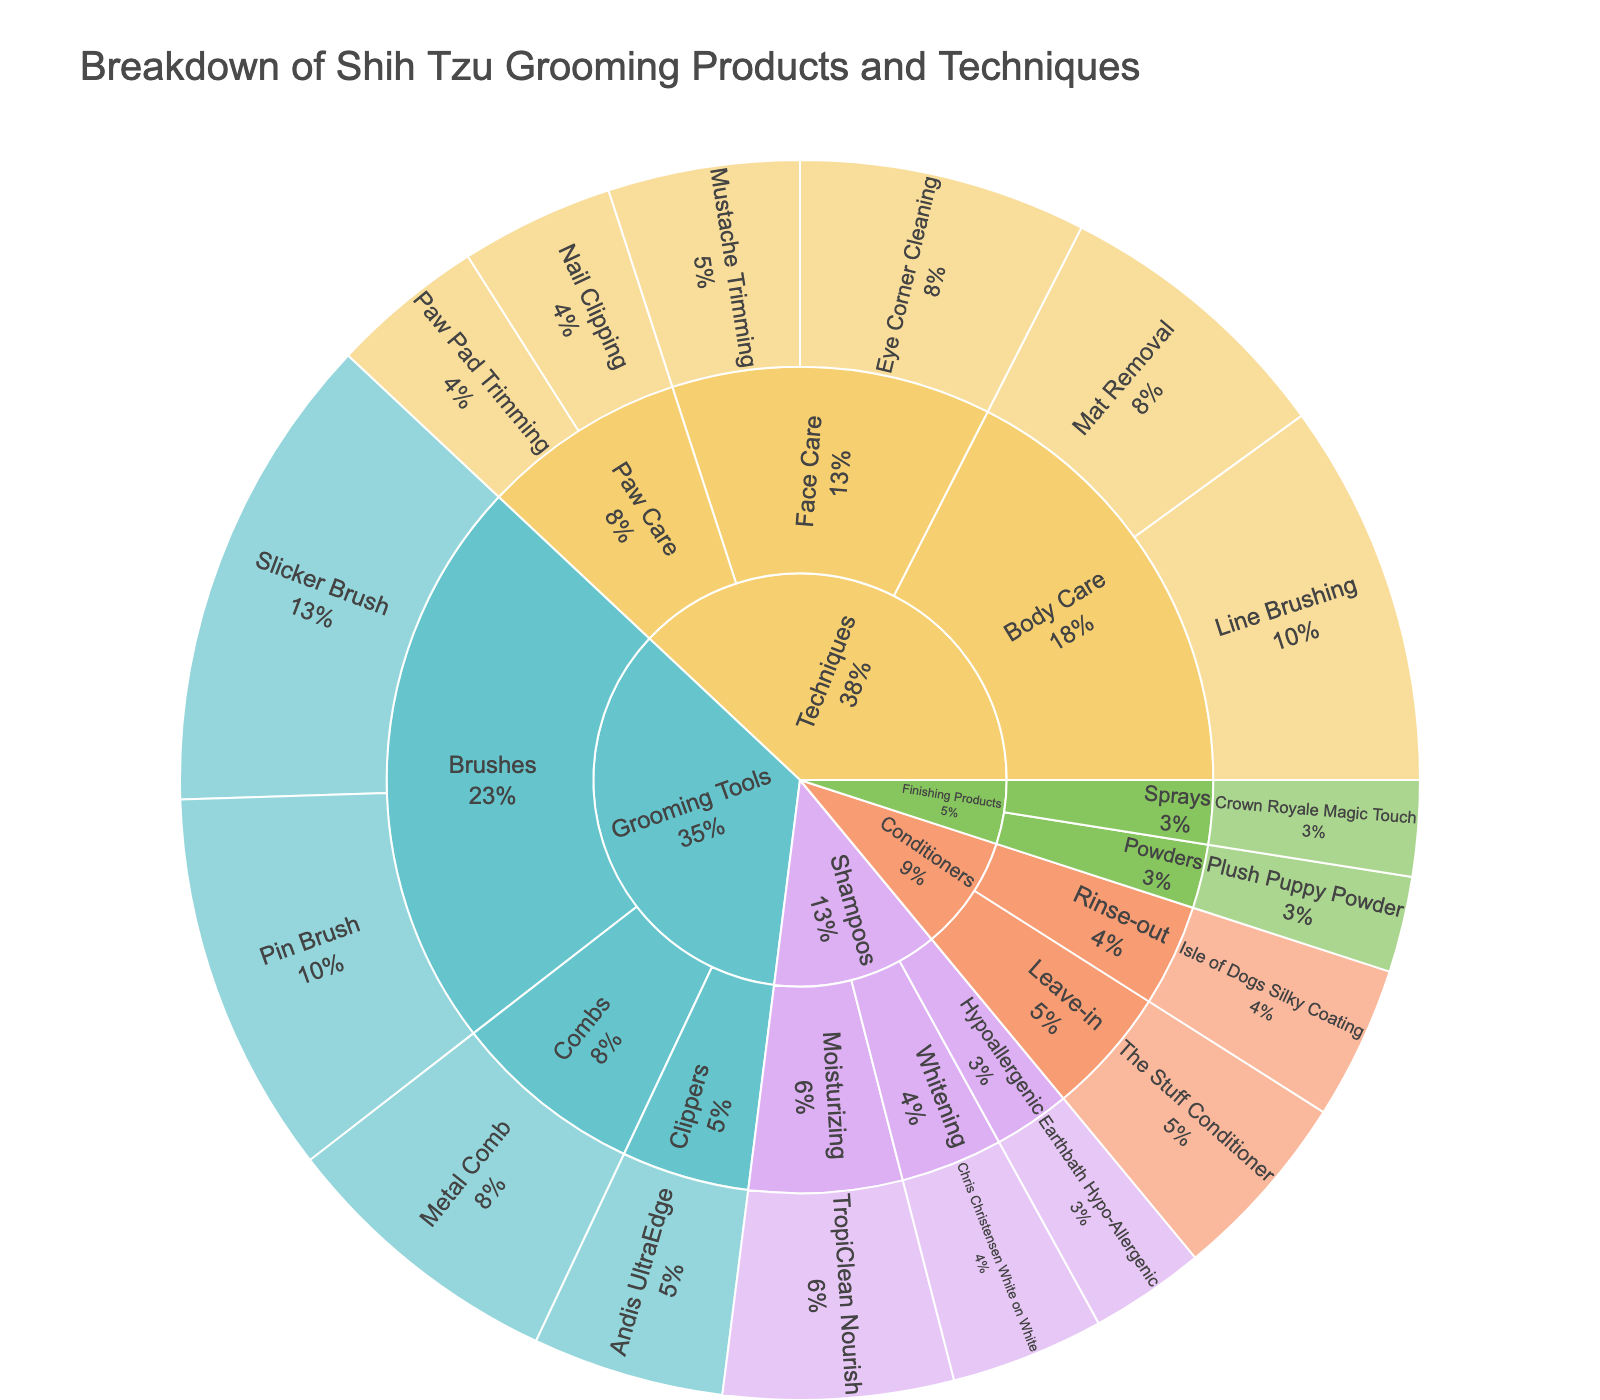what’s the title of the sunburst plot? The title of the sunburst plot is typically displayed at the top of the figure.
Answer: Breakdown of Shih Tzu Grooming Products and Techniques Which category has the most subcategories? By visually inspecting the plot, we can see which section has the most divisions branching out from the central category.
Answer: Techniques Which grooming tool is more common, the Slicker Brush or the Metal Comb? Examine the values associated with each grooming tool under the "Brushes" and "Combs" subcategories in the "Grooming Tools" category.
Answer: Slicker Brush What percentage of the grooming products and techniques are related to face care under the Techniques category? Sum the values for "Face Care" techniques (Eye Corner Cleaning and Mustache Trimming) and divide by the total Techniques category value, then convert to percentage. (15 + 10) / (15 + 10 + 20 + 15 + 8 + 8) = 25 / 76 ≈ 0.3289, or 32.89%
Answer: 32.89% Between "Line Brushing" and "Mat Removal" under Techniques, which one has a higher value? Compare the values directly as given in the plot under the "Techniques > Body Care" subcategory.
Answer: Line Brushing What is the combined value of all leave-in and rinse-out conditioners? Add the values of "The Stuff Conditioner" and "Isle of Dogs Silky Coating" to get the combined total. 10 + 8 = 18
Answer: 18 How do the values compare between the hypoallergenic shampoo and the moisturizing shampoo? Obtain values from the shampoos subcategory and compare them directly.
Answer: The hypoallergenic shampoo value is less than the moisturizing shampoo value Which grooming product has the smallest value? Identify the product with the lowest value from all the categories and subcategories.
Answer: Crown Royale Magic Touch or Plush Puppy Powder (both are 5) Divide the value of Brush techniques by the value of the Pin Brush product. What do you get? Locate the value of "Brushes" and "Pin Brush", then perform the division. (25 + 20) / 20 = 45 / 20 = 2.25
Answer: 2.25 